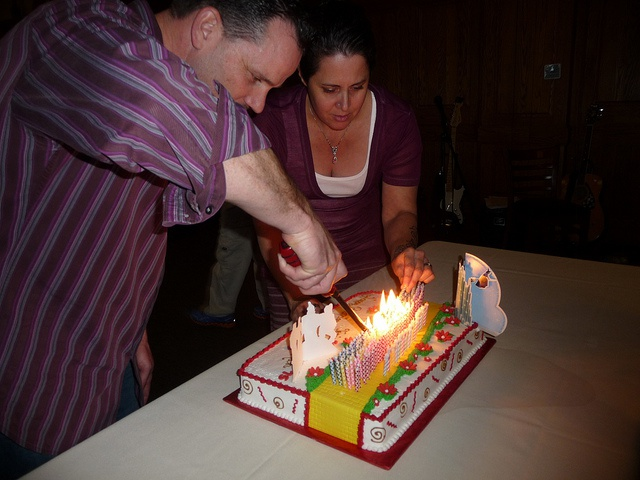Describe the objects in this image and their specific colors. I can see people in black, purple, and brown tones, dining table in black, darkgray, maroon, and gray tones, people in black, maroon, and brown tones, cake in black, darkgray, lightgray, olive, and gray tones, and knife in black, maroon, and brown tones in this image. 